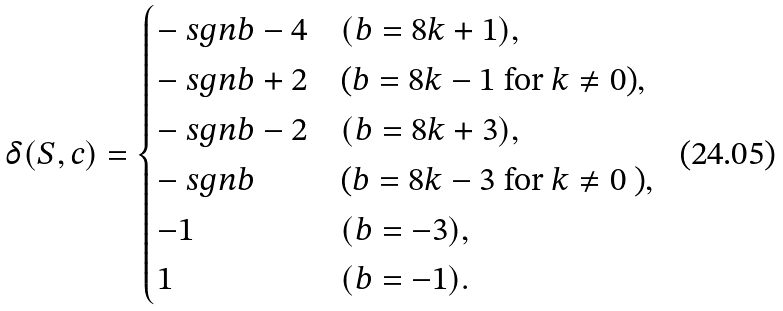Convert formula to latex. <formula><loc_0><loc_0><loc_500><loc_500>\delta ( S , c ) = \begin{cases} - \ s g n b - 4 & ( b = 8 k + 1 ) , \\ - \ s g n b + 2 & \text {($b=8k-1$ for $k\ne 0$)} , \\ - \ s g n b - 2 & ( b = 8 k + 3 ) , \\ - \ s g n b & \text {($b=8k-3$ for $k\ne 0$ )} , \\ - 1 & ( b = - 3 ) , \\ 1 & ( b = - 1 ) . \end{cases}</formula> 